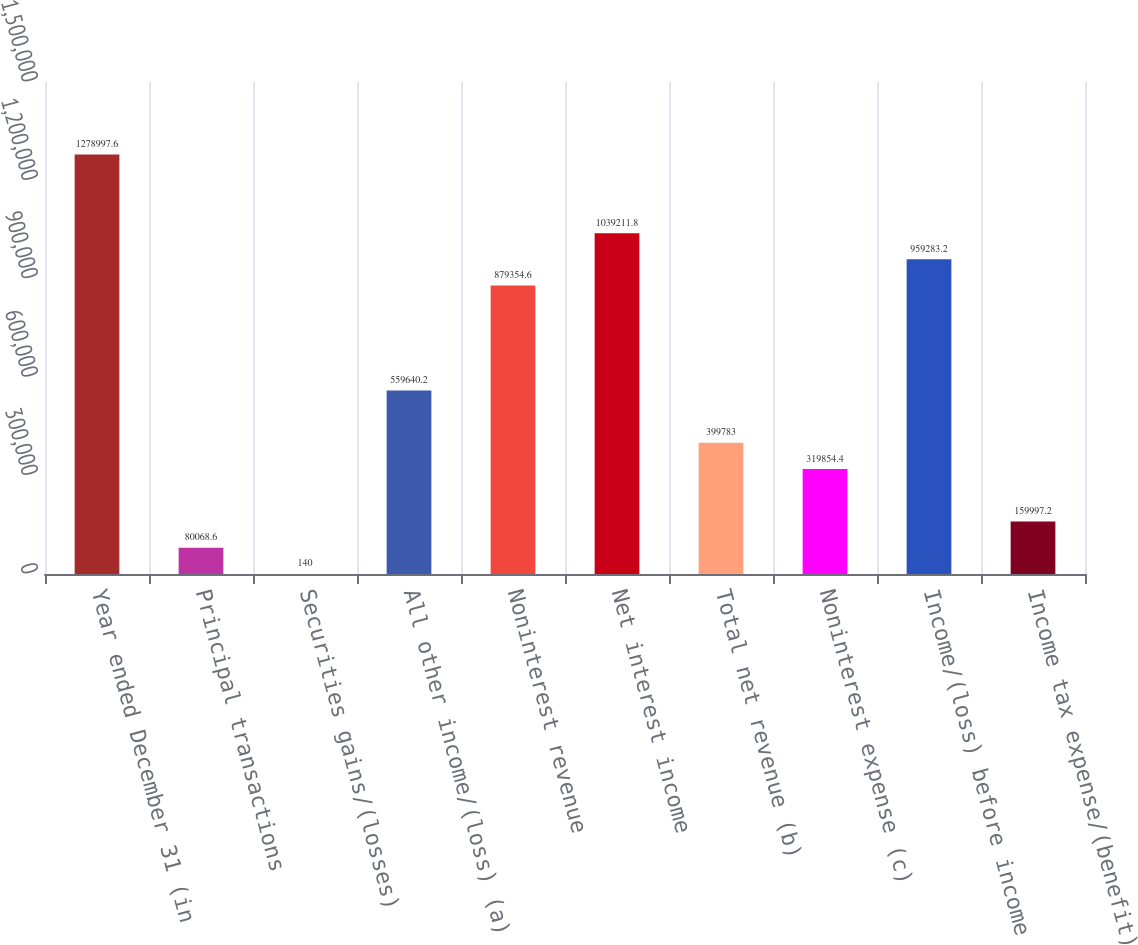Convert chart. <chart><loc_0><loc_0><loc_500><loc_500><bar_chart><fcel>Year ended December 31 (in<fcel>Principal transactions<fcel>Securities gains/(losses)<fcel>All other income/(loss) (a)<fcel>Noninterest revenue<fcel>Net interest income<fcel>Total net revenue (b)<fcel>Noninterest expense (c)<fcel>Income/(loss) before income<fcel>Income tax expense/(benefit)<nl><fcel>1.279e+06<fcel>80068.6<fcel>140<fcel>559640<fcel>879355<fcel>1.03921e+06<fcel>399783<fcel>319854<fcel>959283<fcel>159997<nl></chart> 